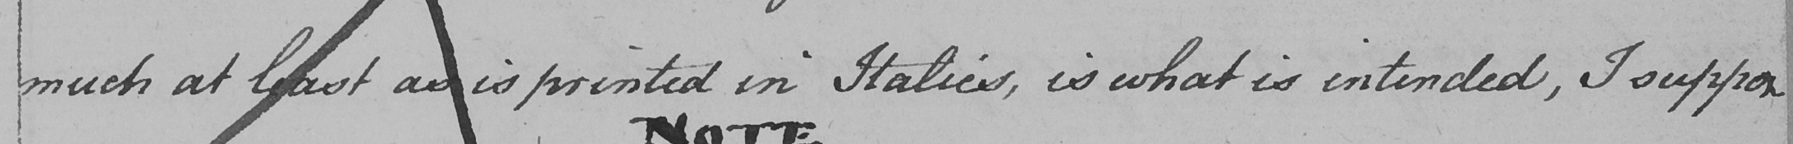What is written in this line of handwriting? much at least as is printed in Italics , is what is intended , I suppose 